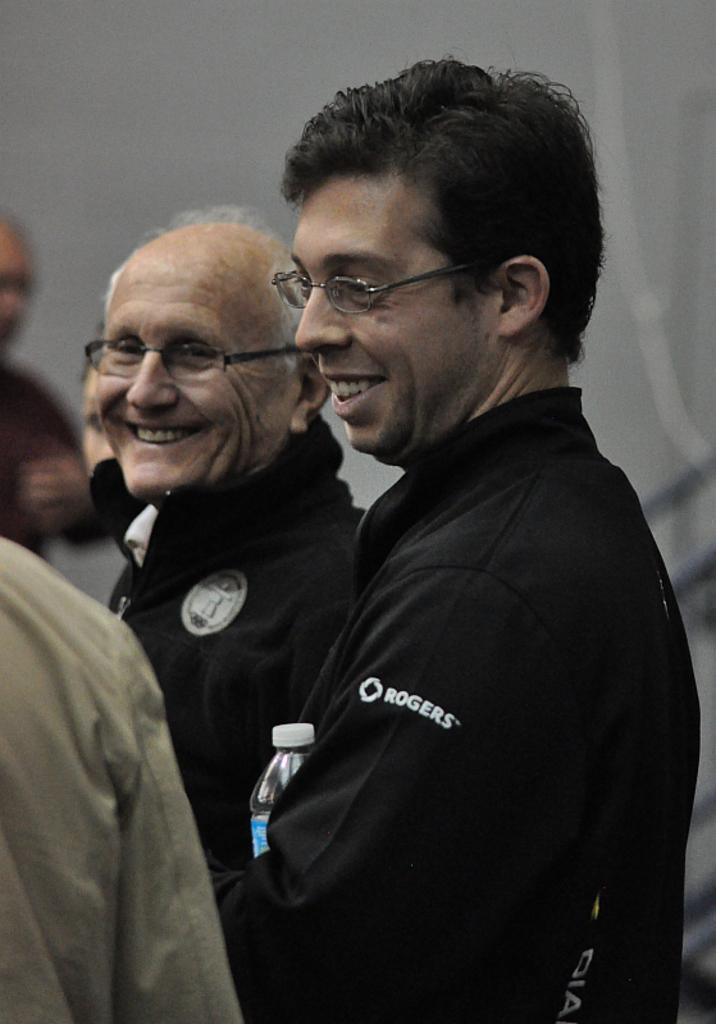Please provide a concise description of this image. In this picture I can see two persons in the middle. They are wearing black color coats and spectacles. 